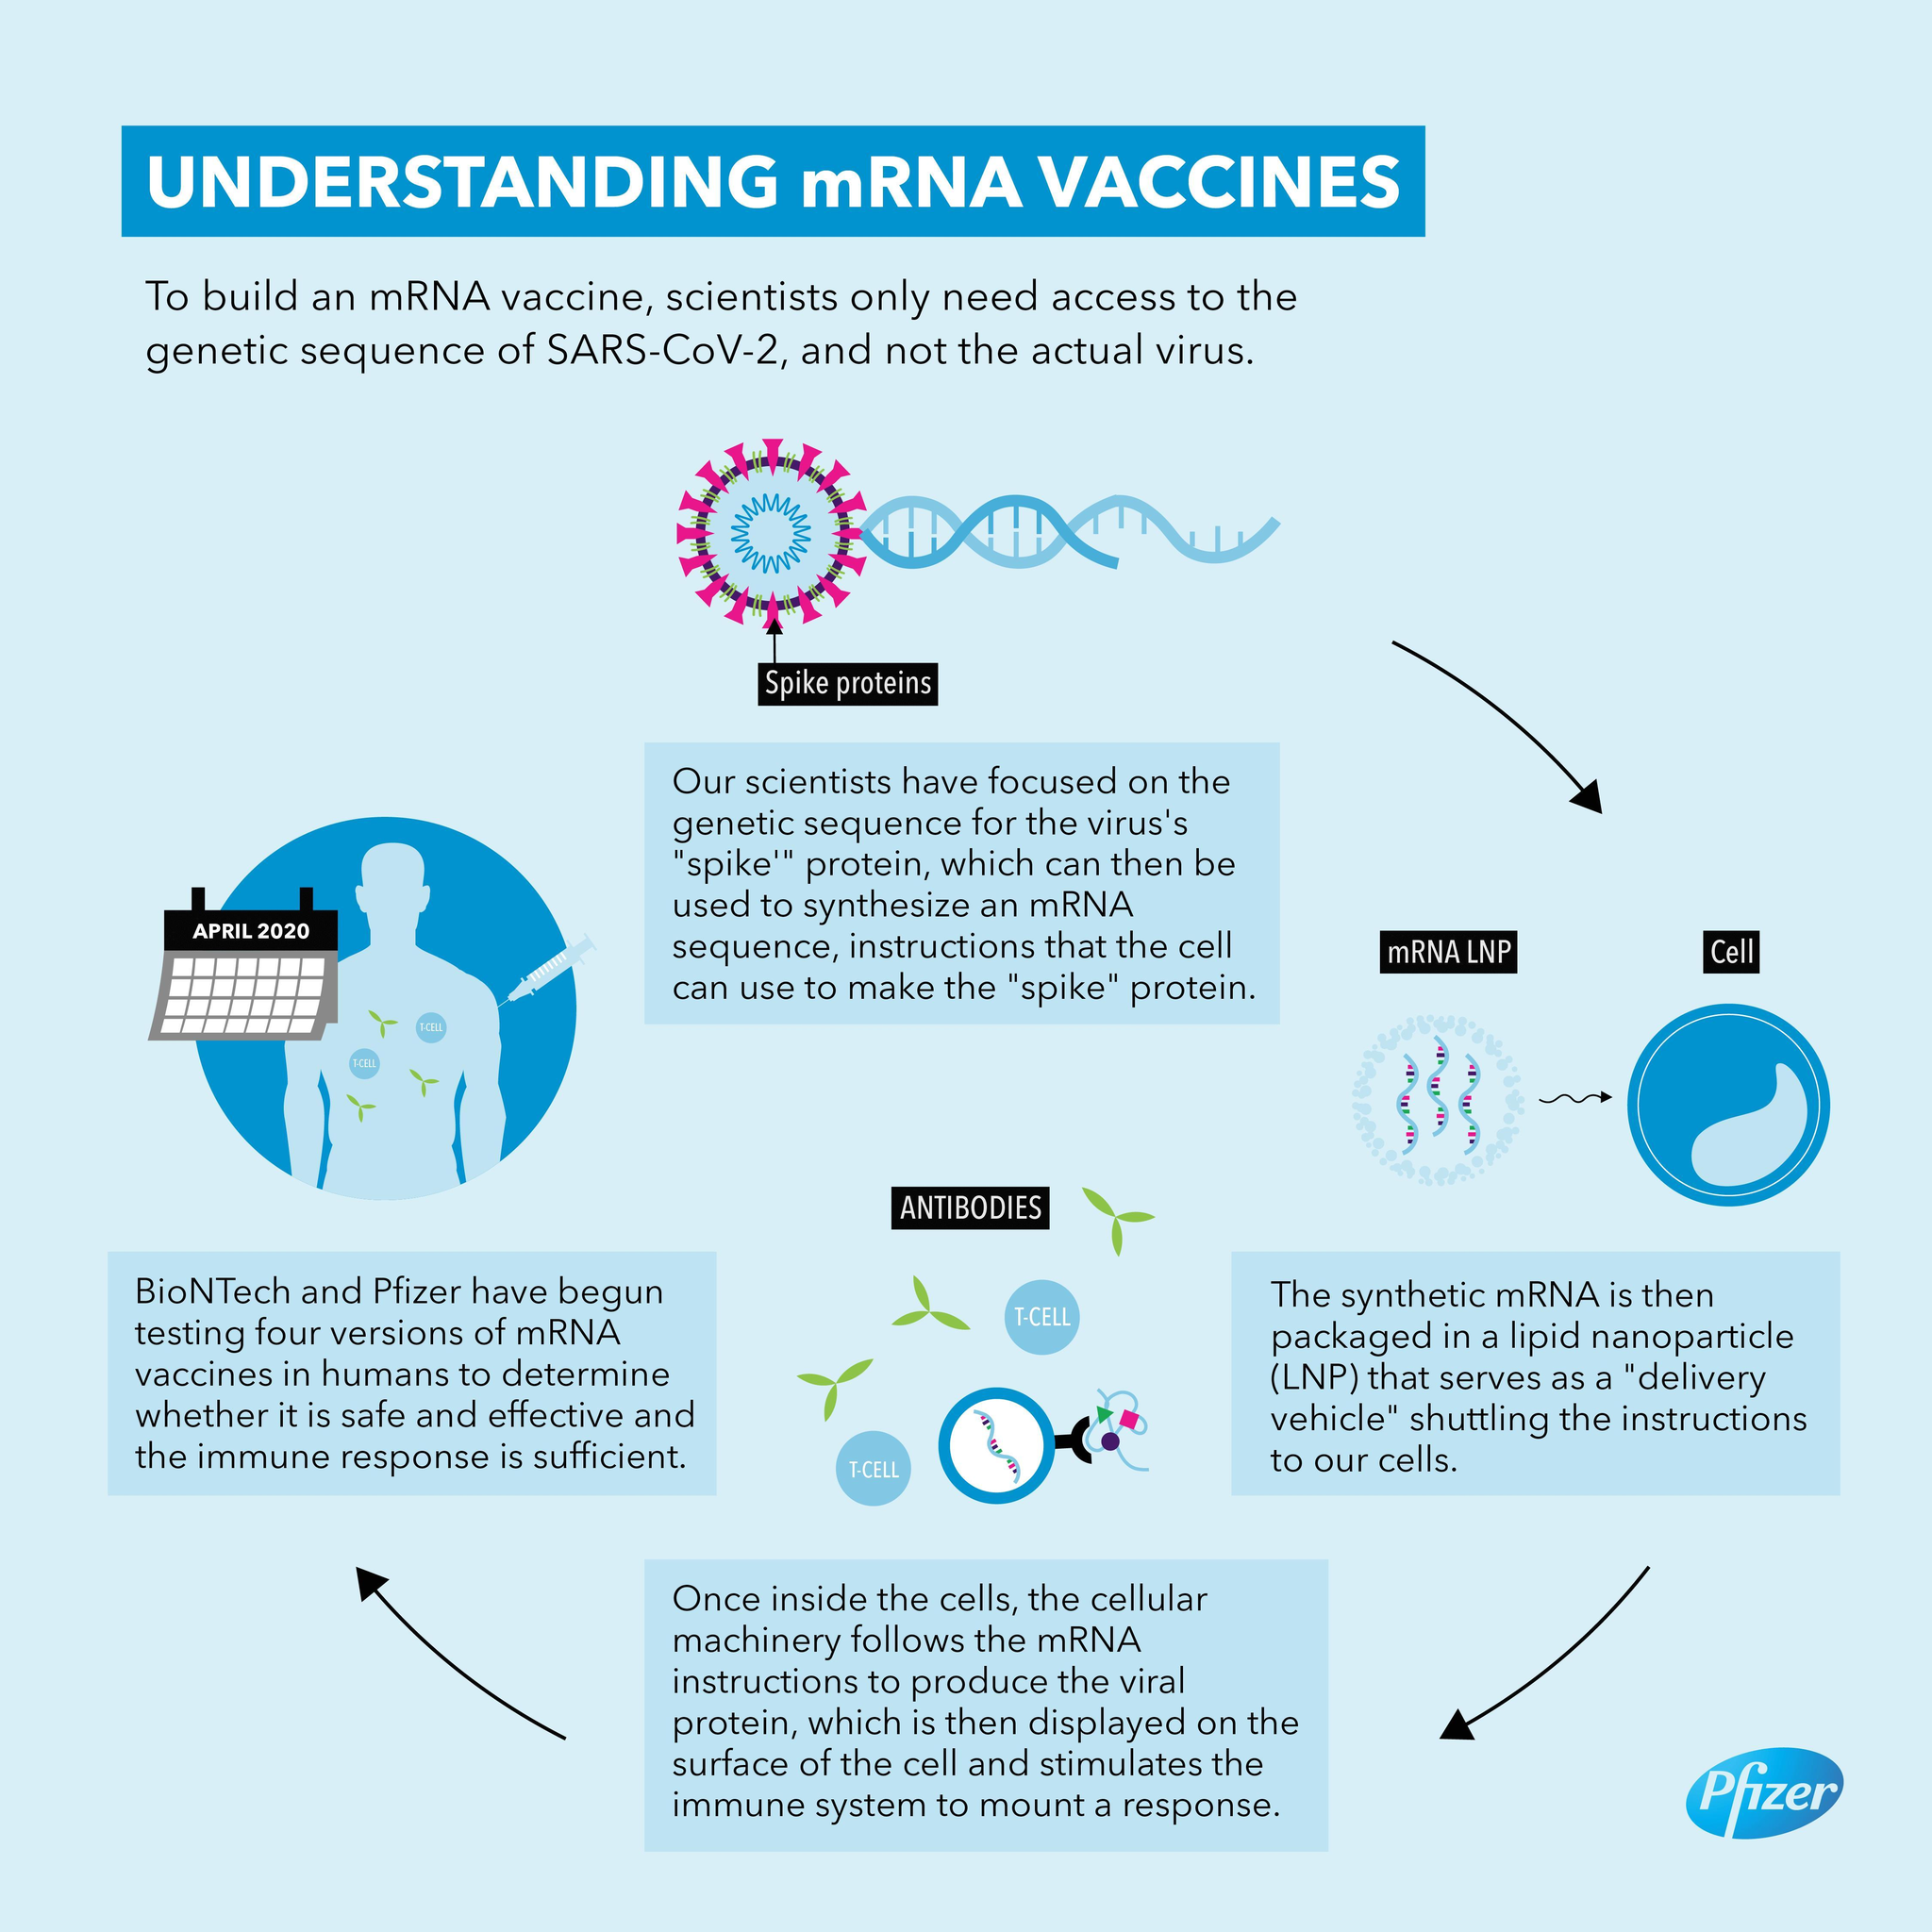How many T-CELLs are in this infographic?
Answer the question with a short phrase. 2 